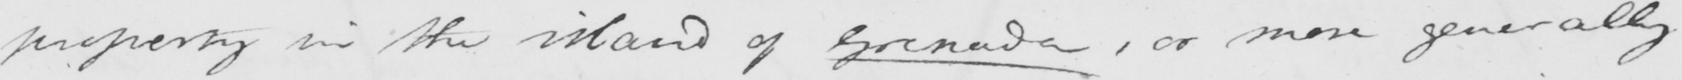What does this handwritten line say? property in the island of Granada , or more generally 